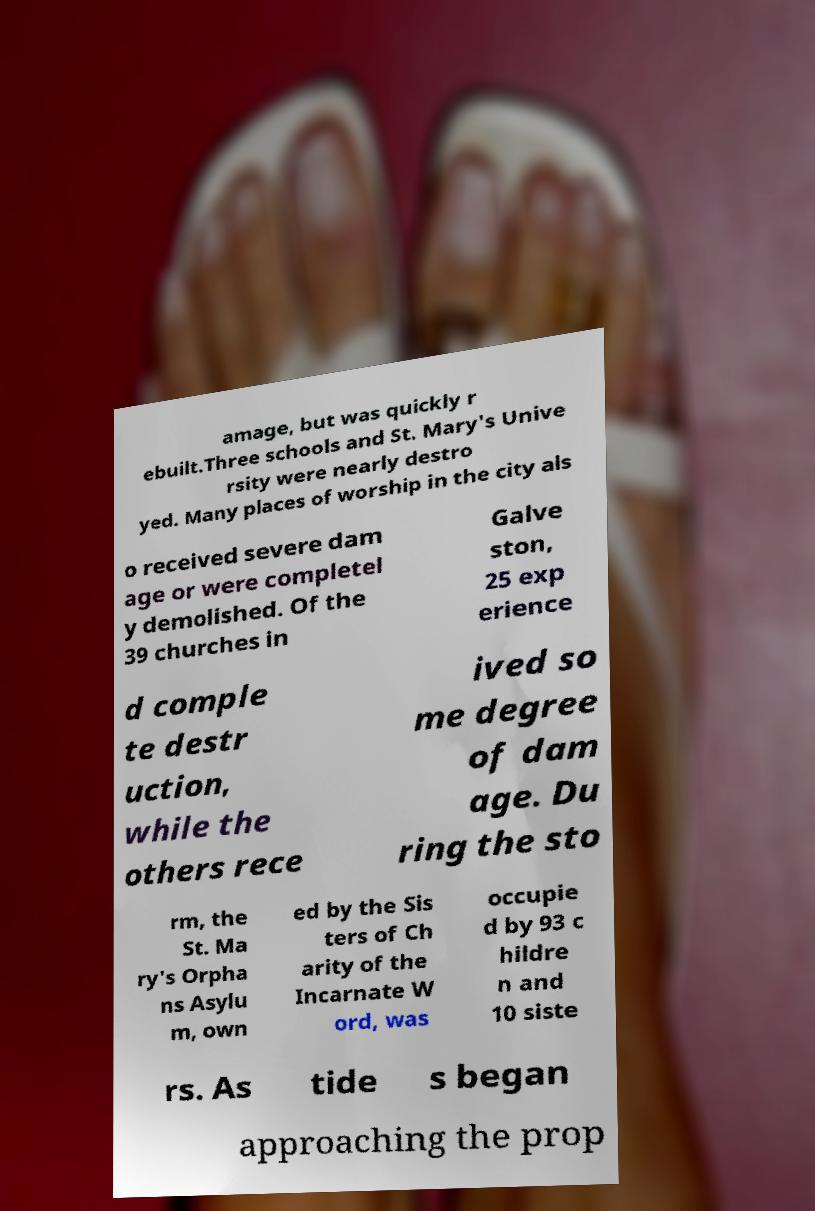For documentation purposes, I need the text within this image transcribed. Could you provide that? amage, but was quickly r ebuilt.Three schools and St. Mary's Unive rsity were nearly destro yed. Many places of worship in the city als o received severe dam age or were completel y demolished. Of the 39 churches in Galve ston, 25 exp erience d comple te destr uction, while the others rece ived so me degree of dam age. Du ring the sto rm, the St. Ma ry's Orpha ns Asylu m, own ed by the Sis ters of Ch arity of the Incarnate W ord, was occupie d by 93 c hildre n and 10 siste rs. As tide s began approaching the prop 